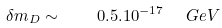<formula> <loc_0><loc_0><loc_500><loc_500>\delta m _ { D } \sim \quad 0 . 5 . 1 0 ^ { - 1 7 } \ \ G e V</formula> 